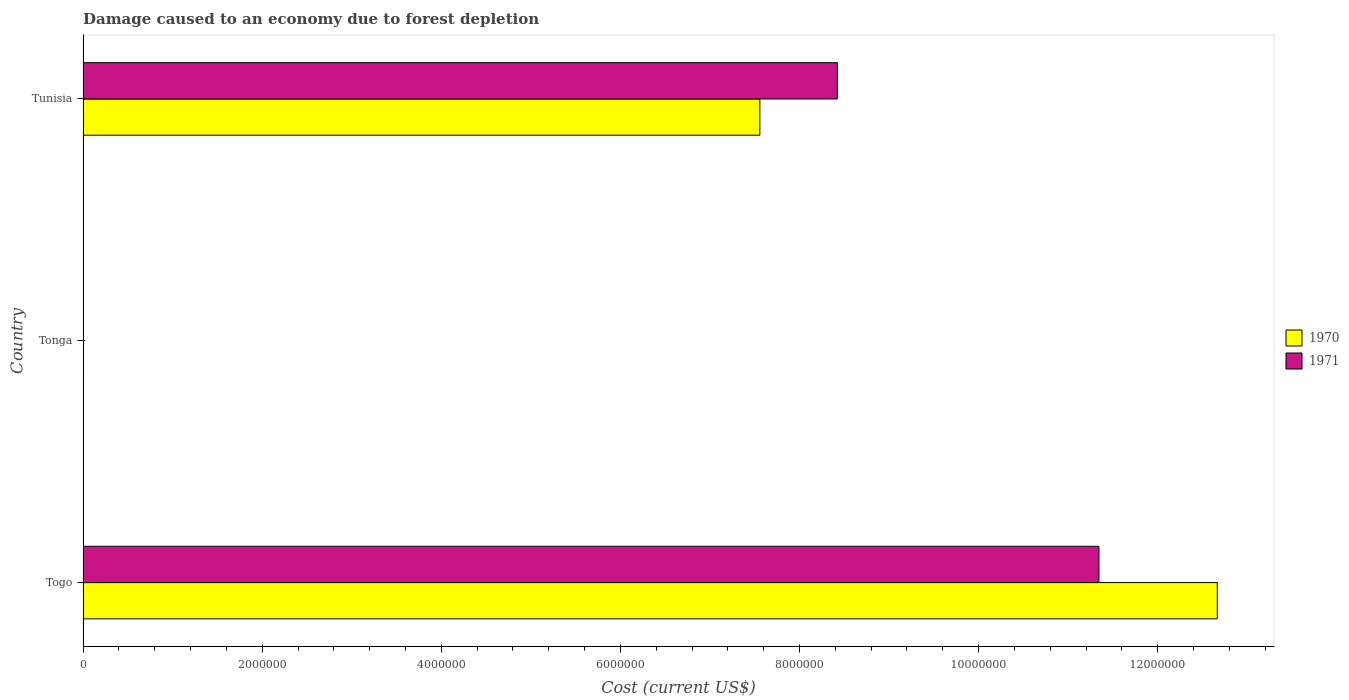How many different coloured bars are there?
Your answer should be compact. 2. Are the number of bars per tick equal to the number of legend labels?
Give a very brief answer. Yes. How many bars are there on the 3rd tick from the bottom?
Offer a terse response. 2. What is the label of the 3rd group of bars from the top?
Offer a very short reply. Togo. In how many cases, is the number of bars for a given country not equal to the number of legend labels?
Give a very brief answer. 0. What is the cost of damage caused due to forest depletion in 1971 in Tonga?
Give a very brief answer. 4376.43. Across all countries, what is the maximum cost of damage caused due to forest depletion in 1970?
Keep it short and to the point. 1.27e+07. Across all countries, what is the minimum cost of damage caused due to forest depletion in 1971?
Provide a short and direct response. 4376.43. In which country was the cost of damage caused due to forest depletion in 1971 maximum?
Your response must be concise. Togo. In which country was the cost of damage caused due to forest depletion in 1970 minimum?
Give a very brief answer. Tonga. What is the total cost of damage caused due to forest depletion in 1970 in the graph?
Keep it short and to the point. 2.02e+07. What is the difference between the cost of damage caused due to forest depletion in 1971 in Togo and that in Tonga?
Offer a very short reply. 1.13e+07. What is the difference between the cost of damage caused due to forest depletion in 1970 in Tonga and the cost of damage caused due to forest depletion in 1971 in Togo?
Provide a short and direct response. -1.13e+07. What is the average cost of damage caused due to forest depletion in 1971 per country?
Provide a succinct answer. 6.59e+06. What is the difference between the cost of damage caused due to forest depletion in 1970 and cost of damage caused due to forest depletion in 1971 in Tunisia?
Your response must be concise. -8.66e+05. What is the ratio of the cost of damage caused due to forest depletion in 1971 in Tonga to that in Tunisia?
Keep it short and to the point. 0. Is the cost of damage caused due to forest depletion in 1971 in Togo less than that in Tunisia?
Offer a terse response. No. What is the difference between the highest and the second highest cost of damage caused due to forest depletion in 1970?
Make the answer very short. 5.11e+06. What is the difference between the highest and the lowest cost of damage caused due to forest depletion in 1971?
Your response must be concise. 1.13e+07. Is the sum of the cost of damage caused due to forest depletion in 1971 in Togo and Tonga greater than the maximum cost of damage caused due to forest depletion in 1970 across all countries?
Offer a terse response. No. Are all the bars in the graph horizontal?
Give a very brief answer. Yes. How many countries are there in the graph?
Offer a very short reply. 3. Does the graph contain grids?
Offer a very short reply. No. Where does the legend appear in the graph?
Give a very brief answer. Center right. How many legend labels are there?
Offer a very short reply. 2. What is the title of the graph?
Your answer should be very brief. Damage caused to an economy due to forest depletion. What is the label or title of the X-axis?
Your answer should be very brief. Cost (current US$). What is the Cost (current US$) of 1970 in Togo?
Keep it short and to the point. 1.27e+07. What is the Cost (current US$) in 1971 in Togo?
Provide a short and direct response. 1.13e+07. What is the Cost (current US$) of 1970 in Tonga?
Provide a succinct answer. 4901.94. What is the Cost (current US$) in 1971 in Tonga?
Provide a succinct answer. 4376.43. What is the Cost (current US$) in 1970 in Tunisia?
Give a very brief answer. 7.56e+06. What is the Cost (current US$) in 1971 in Tunisia?
Make the answer very short. 8.42e+06. Across all countries, what is the maximum Cost (current US$) in 1970?
Give a very brief answer. 1.27e+07. Across all countries, what is the maximum Cost (current US$) in 1971?
Offer a very short reply. 1.13e+07. Across all countries, what is the minimum Cost (current US$) in 1970?
Make the answer very short. 4901.94. Across all countries, what is the minimum Cost (current US$) in 1971?
Your response must be concise. 4376.43. What is the total Cost (current US$) of 1970 in the graph?
Provide a succinct answer. 2.02e+07. What is the total Cost (current US$) of 1971 in the graph?
Ensure brevity in your answer.  1.98e+07. What is the difference between the Cost (current US$) in 1970 in Togo and that in Tonga?
Your response must be concise. 1.27e+07. What is the difference between the Cost (current US$) of 1971 in Togo and that in Tonga?
Offer a terse response. 1.13e+07. What is the difference between the Cost (current US$) in 1970 in Togo and that in Tunisia?
Give a very brief answer. 5.11e+06. What is the difference between the Cost (current US$) of 1971 in Togo and that in Tunisia?
Give a very brief answer. 2.92e+06. What is the difference between the Cost (current US$) of 1970 in Tonga and that in Tunisia?
Your response must be concise. -7.55e+06. What is the difference between the Cost (current US$) in 1971 in Tonga and that in Tunisia?
Your answer should be compact. -8.42e+06. What is the difference between the Cost (current US$) in 1970 in Togo and the Cost (current US$) in 1971 in Tonga?
Keep it short and to the point. 1.27e+07. What is the difference between the Cost (current US$) of 1970 in Togo and the Cost (current US$) of 1971 in Tunisia?
Make the answer very short. 4.24e+06. What is the difference between the Cost (current US$) in 1970 in Tonga and the Cost (current US$) in 1971 in Tunisia?
Offer a very short reply. -8.42e+06. What is the average Cost (current US$) in 1970 per country?
Make the answer very short. 6.74e+06. What is the average Cost (current US$) of 1971 per country?
Provide a succinct answer. 6.59e+06. What is the difference between the Cost (current US$) of 1970 and Cost (current US$) of 1971 in Togo?
Your answer should be very brief. 1.32e+06. What is the difference between the Cost (current US$) of 1970 and Cost (current US$) of 1971 in Tonga?
Provide a succinct answer. 525.51. What is the difference between the Cost (current US$) of 1970 and Cost (current US$) of 1971 in Tunisia?
Give a very brief answer. -8.66e+05. What is the ratio of the Cost (current US$) in 1970 in Togo to that in Tonga?
Provide a short and direct response. 2583.92. What is the ratio of the Cost (current US$) in 1971 in Togo to that in Tonga?
Provide a short and direct response. 2592.16. What is the ratio of the Cost (current US$) of 1970 in Togo to that in Tunisia?
Provide a short and direct response. 1.68. What is the ratio of the Cost (current US$) of 1971 in Togo to that in Tunisia?
Offer a terse response. 1.35. What is the ratio of the Cost (current US$) of 1970 in Tonga to that in Tunisia?
Provide a succinct answer. 0. What is the ratio of the Cost (current US$) of 1971 in Tonga to that in Tunisia?
Offer a very short reply. 0. What is the difference between the highest and the second highest Cost (current US$) in 1970?
Provide a succinct answer. 5.11e+06. What is the difference between the highest and the second highest Cost (current US$) of 1971?
Keep it short and to the point. 2.92e+06. What is the difference between the highest and the lowest Cost (current US$) of 1970?
Your response must be concise. 1.27e+07. What is the difference between the highest and the lowest Cost (current US$) of 1971?
Your answer should be compact. 1.13e+07. 